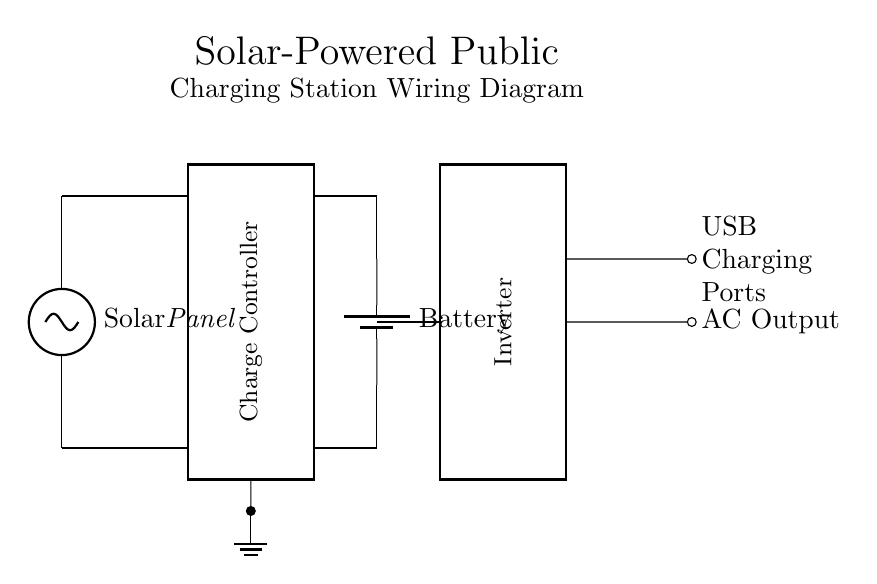What type of primary energy source is used? The primary energy source shown is a solar panel, indicated by the labeled symbol for the solar panel in the circuit diagram.
Answer: Solar panel What component is responsible for managing battery charging? The charge controller is responsible for managing battery charging, as it is clearly marked and connected to the solar panel and battery.
Answer: Charge controller How many USB charging ports are available? The USB charging ports are indicated in the diagram and there are two short connections labeled as USB Charging Ports.
Answer: Two What is the direction of current flow from the solar panel? The current flows from the solar panel into the charge controller, shown by the line connecting them and the direction indicated by the diagram layout.
Answer: From solar panel to charge controller What is the purpose of the inverter in this circuit? The inverter converts direct current from the battery to alternating current for use at the AC output, as indicated by its function in the diagram.
Answer: Convert DC to AC Which component connects the battery to the inverter? The wire connects the battery to the inverter, shading a path from the battery directly into the inverter's input, allowing energy transfer.
Answer: Wire What does the ground symbol indicate in the circuit? The ground symbol indicates a reference point for the circuit's voltage levels and safety, connecting to the charge controller which helps stabilize the circuit.
Answer: Reference point 